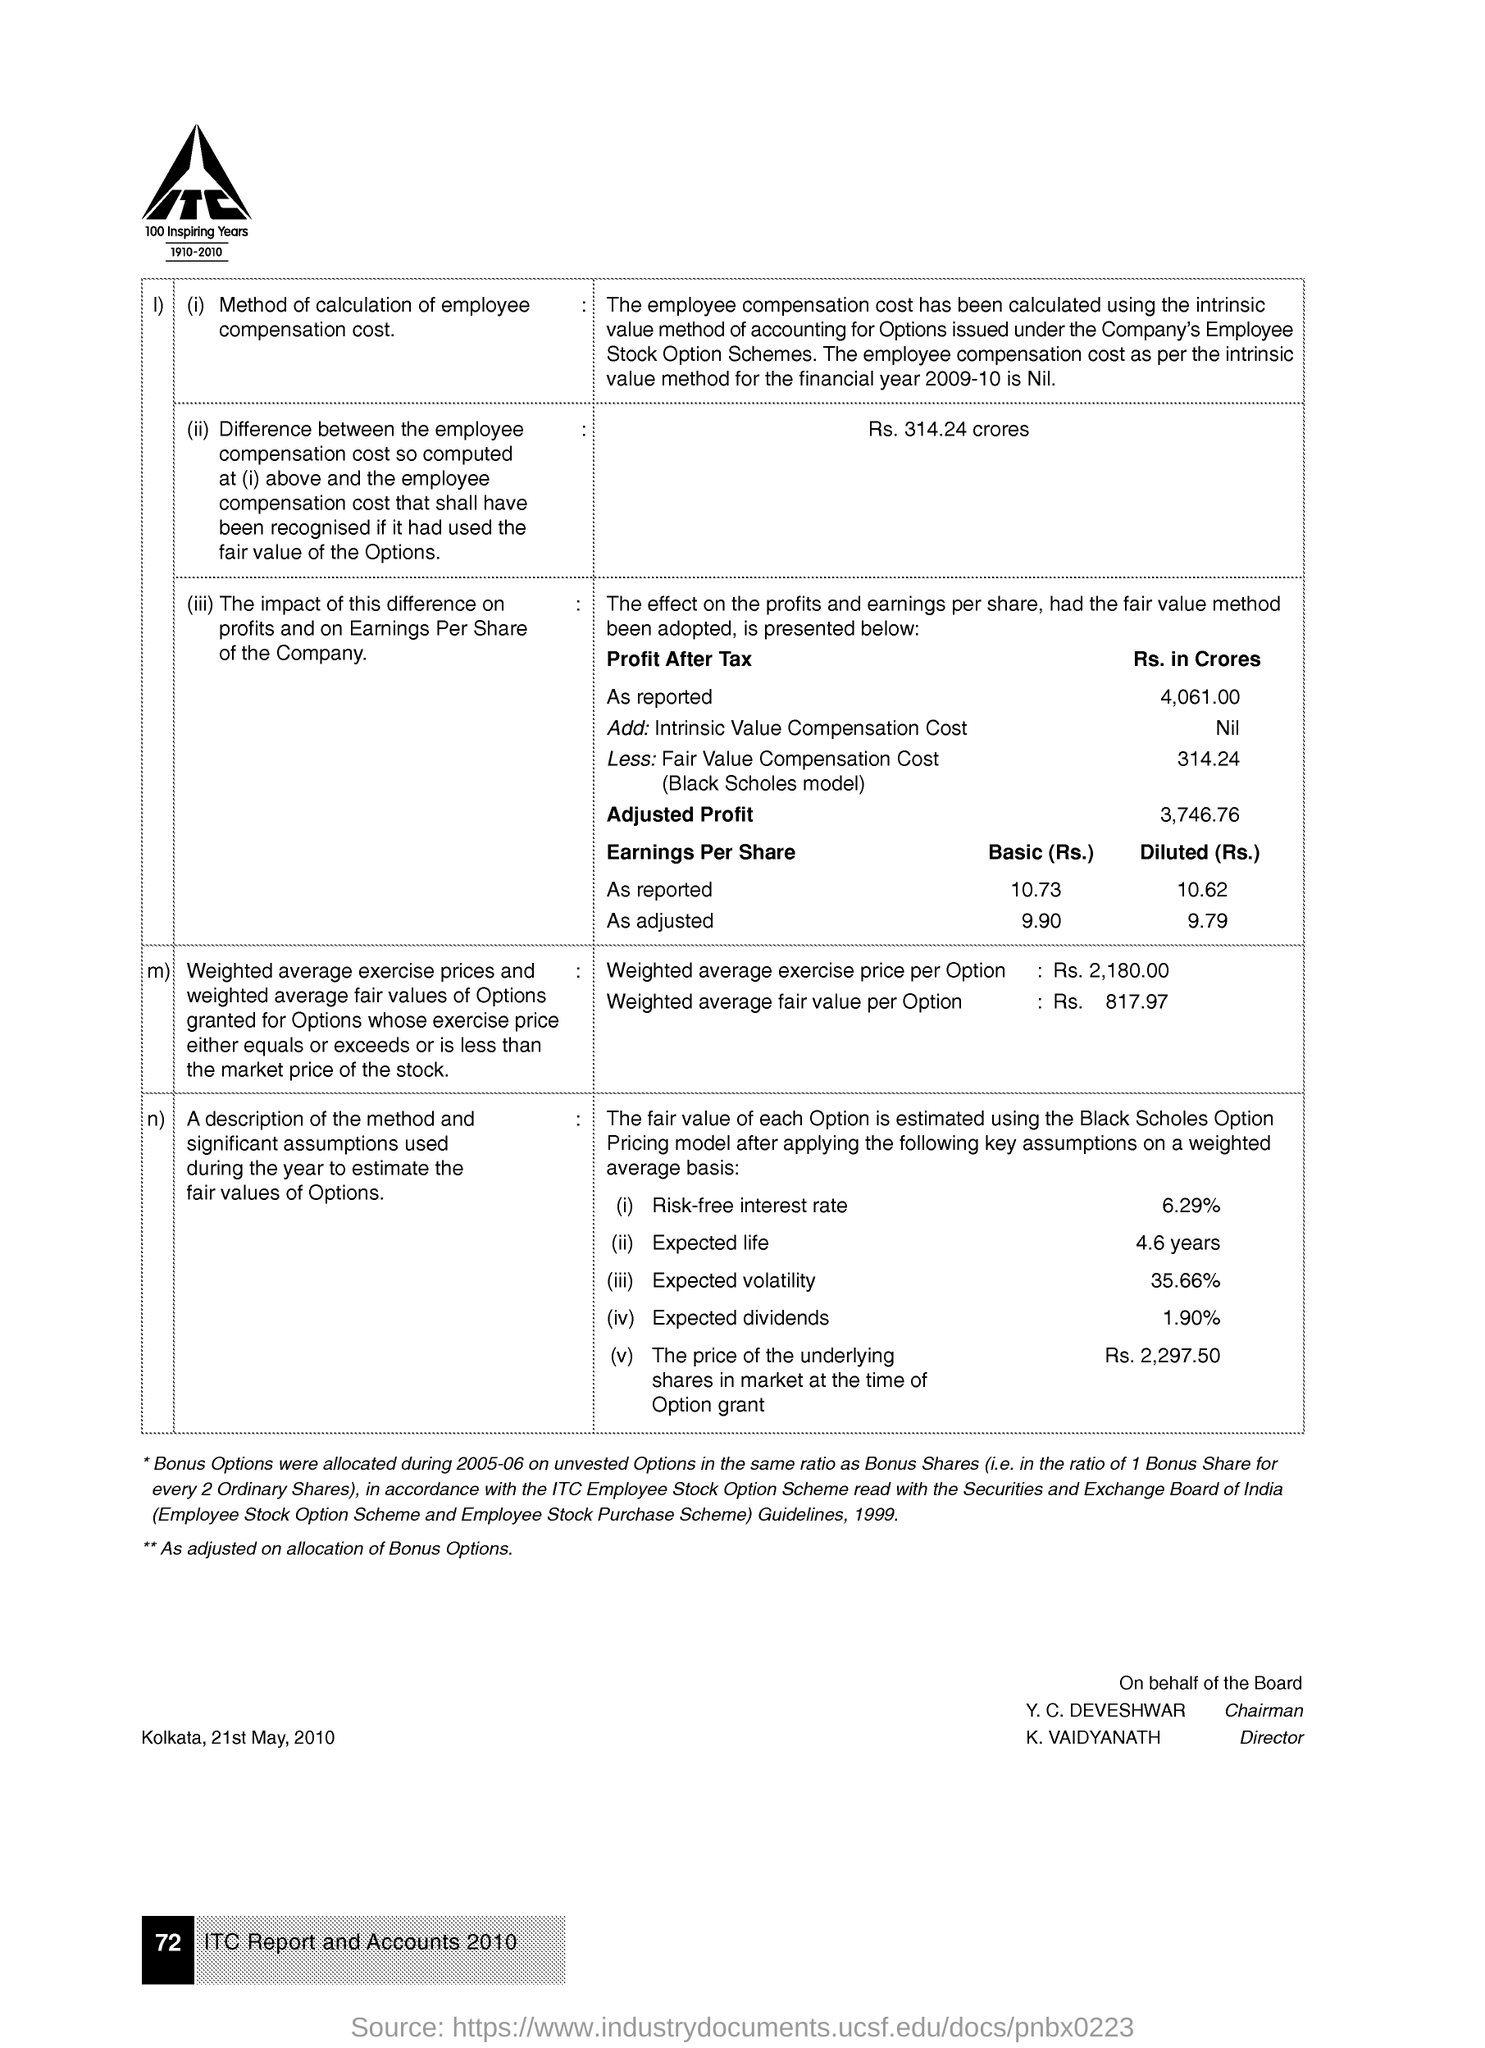Who is the Director?
Give a very brief answer. K. Vaidyanath. What is the weighted average exercise price per option?
Give a very brief answer. Rs. 2,180.00. What is the weighted average fair value per option?
Offer a terse response. Rs. 817.97. What is the Risk-free interest rate?
Provide a succinct answer. 6.29%. What is the Expected life?
Offer a terse response. 4.6 years. What is the Expected volatility?
Your answer should be compact. 35.66%. 